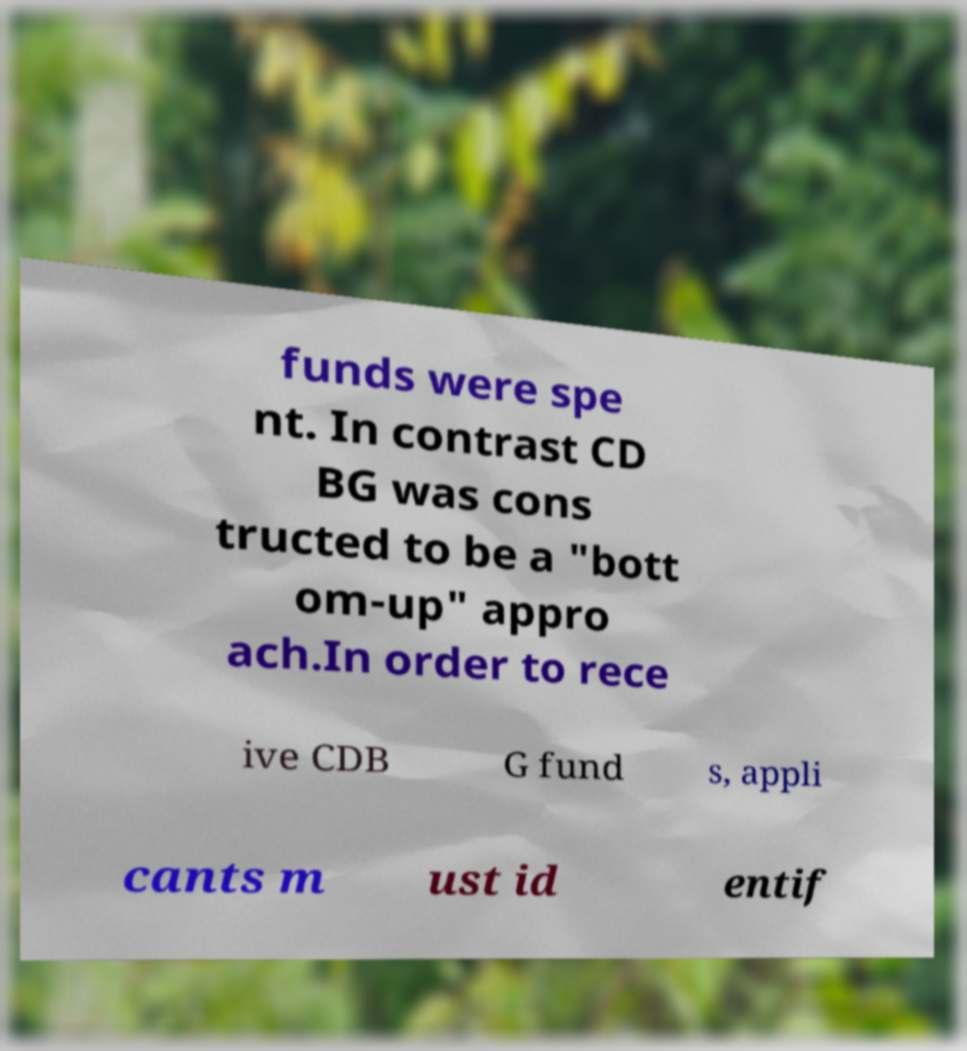Can you read and provide the text displayed in the image?This photo seems to have some interesting text. Can you extract and type it out for me? funds were spe nt. In contrast CD BG was cons tructed to be a "bott om-up" appro ach.In order to rece ive CDB G fund s, appli cants m ust id entif 